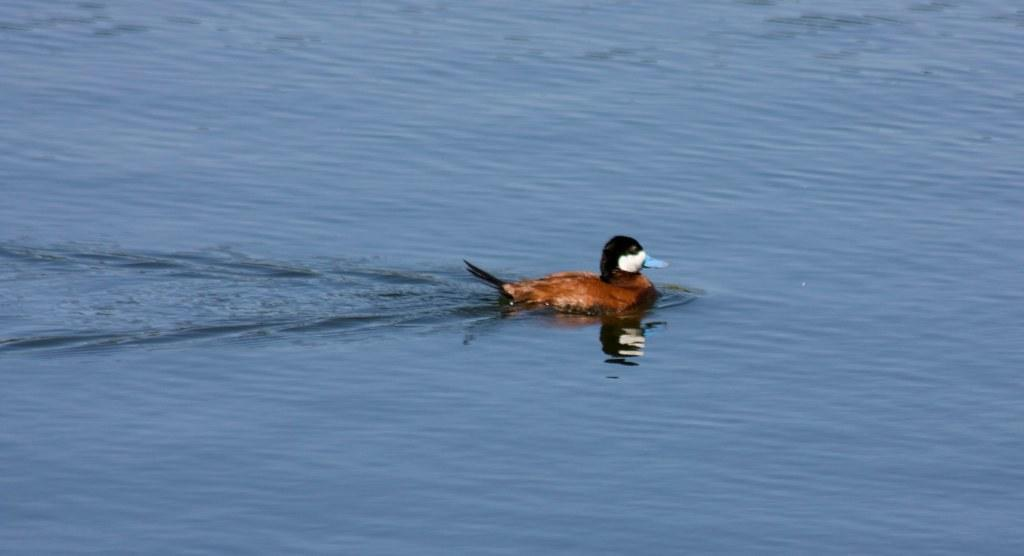What animal is in the water in the image? There is a duck in the water in the image. Can you describe any additional features related to the duck? There is a reflection of the duck on the water. What type of scissors can be seen cutting the duck's feathers in the image? There are no scissors or any cutting activity involving the duck's feathers in the image. 